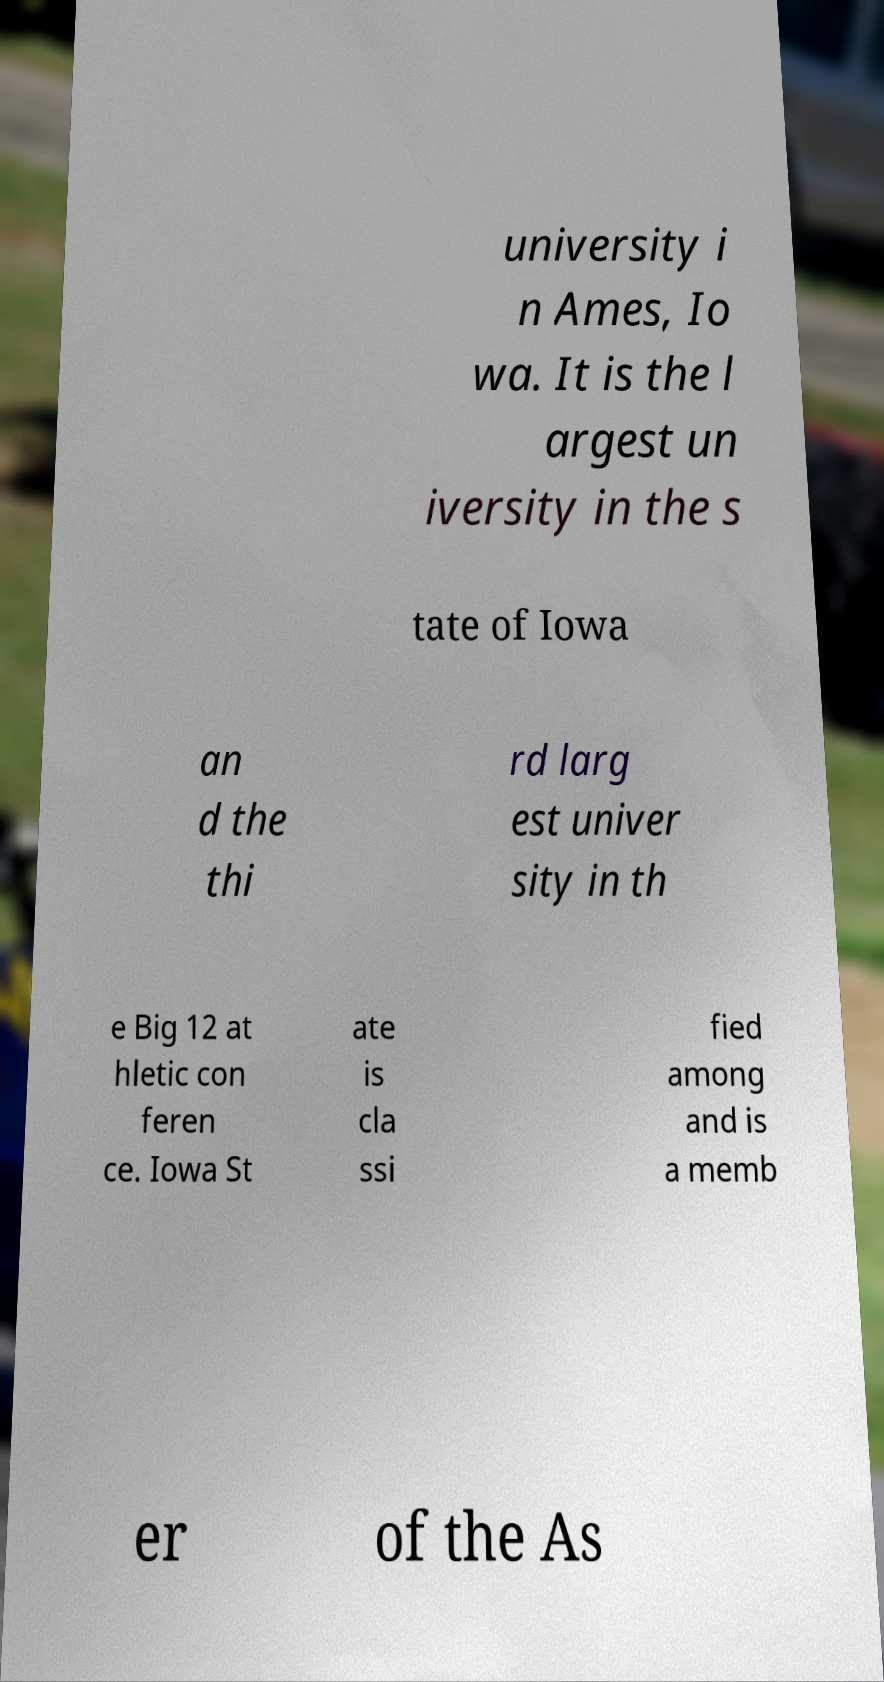For documentation purposes, I need the text within this image transcribed. Could you provide that? university i n Ames, Io wa. It is the l argest un iversity in the s tate of Iowa an d the thi rd larg est univer sity in th e Big 12 at hletic con feren ce. Iowa St ate is cla ssi fied among and is a memb er of the As 